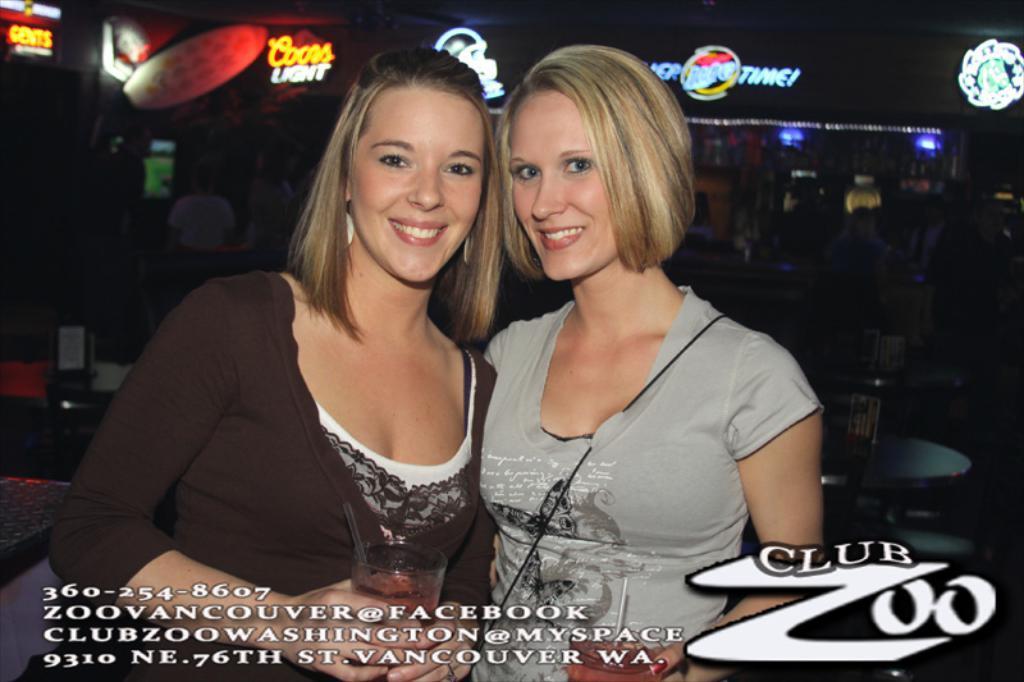In one or two sentences, can you explain what this image depicts? In this picture we can see two women holding glasses in their hands. We can see the straws and liquid in these glasses. There is some text and numbers are visible at the bottom of the picture. There are a few objects visible on the tables. We can see a few people at the back. There is a screen on the left side. We can see lights and some text on top of the picture. 